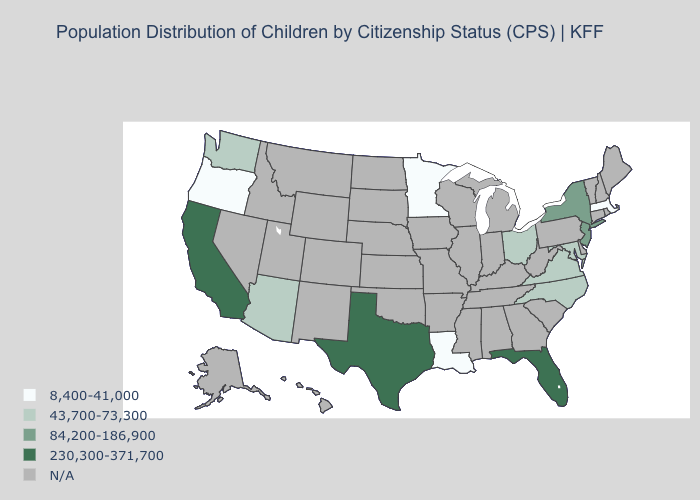Is the legend a continuous bar?
Short answer required. No. Name the states that have a value in the range 230,300-371,700?
Short answer required. California, Florida, Texas. Does the first symbol in the legend represent the smallest category?
Give a very brief answer. Yes. Name the states that have a value in the range 8,400-41,000?
Write a very short answer. Louisiana, Massachusetts, Minnesota, Oregon. Does Minnesota have the highest value in the USA?
Give a very brief answer. No. Does the first symbol in the legend represent the smallest category?
Give a very brief answer. Yes. What is the highest value in the West ?
Answer briefly. 230,300-371,700. Which states have the lowest value in the MidWest?
Answer briefly. Minnesota. Does Florida have the highest value in the USA?
Keep it brief. Yes. What is the lowest value in the South?
Give a very brief answer. 8,400-41,000. What is the lowest value in states that border Connecticut?
Write a very short answer. 8,400-41,000. Name the states that have a value in the range 230,300-371,700?
Answer briefly. California, Florida, Texas. 